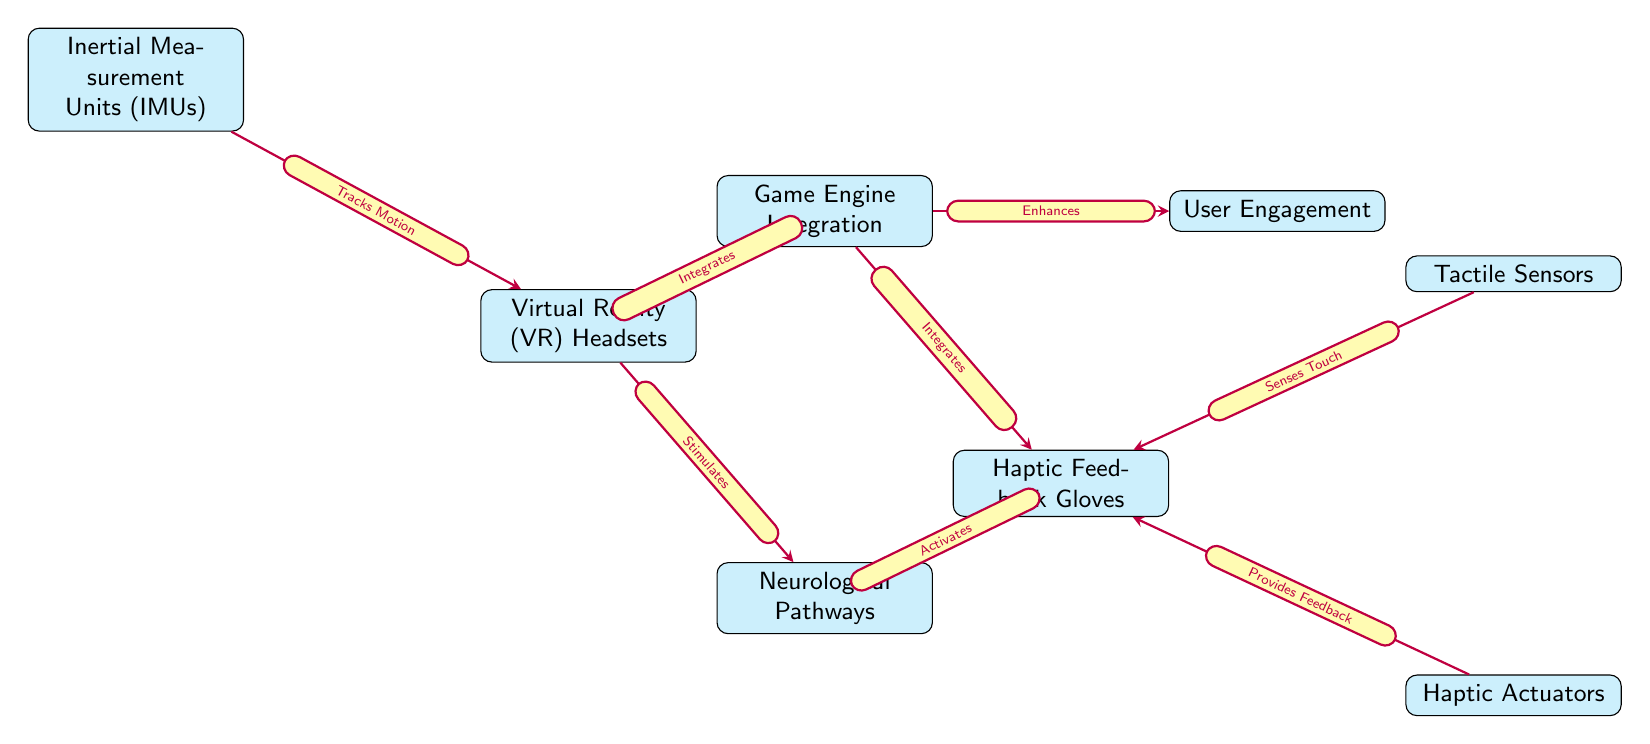What is the main technology represented at the center bottom of the diagram? The main technology at the center bottom of the diagram is "Neurological Pathways," which connects and is influenced by both Virtual Reality and Haptic Feedback technologies.
Answer: Neurological Pathways How many nodes are representing technologies in this diagram? The diagram contains five nodes that represent technologies: Virtual Reality Headsets, Haptic Feedback Gloves, Inertial Measurement Units, Tactile Sensors, and Haptic Actuators.
Answer: Five What does the arrow from Virtual Reality Headsets to Neurological Pathways indicate? The arrow labeled "Stimulates" indicates that Virtual Reality Headsets have an impact on Neurological Pathways, suggesting that they engage or activate these pathways during use.
Answer: Stimulates Which component provides feedback to the Haptic Feedback Gloves? The component that provides feedback to the Haptic Feedback Gloves is "Haptic Actuators," as indicated by the arrow labeled "Provides Feedback" in the diagram.
Answer: Haptic Actuators What is the relationship between Game Engine Integration and User Engagement? The diagram shows that Game Engine Integration enhances User Engagement. This implies that the better the integration, the more it can improve how users interact with the game.
Answer: Enhances How does Inertial Measurement Units interact with Virtual Reality Headsets? Inertial Measurement Units are represented in the diagram as tracking motion that impacts the functioning of Virtual Reality Headsets, indicating their role in enhancing the VR experience.
Answer: Tracks Motion What role do Tactile Sensors play in the context of Haptic Feedback Gloves? The Tactile Sensors sense touch, which is crucial for the functionality and responsiveness of Haptic Feedback Gloves, ensuring a more immersive experience by detecting user interactions.
Answer: Senses Touch Which technology interacts with both the Virtual Reality Headsets and Haptic Feedback Gloves? The technology that interacts with both Virtual Reality Headsets and Haptic Feedback Gloves is "Game Engine Integration," illustrated in the diagram with connections to both nodes.
Answer: Game Engine Integration 